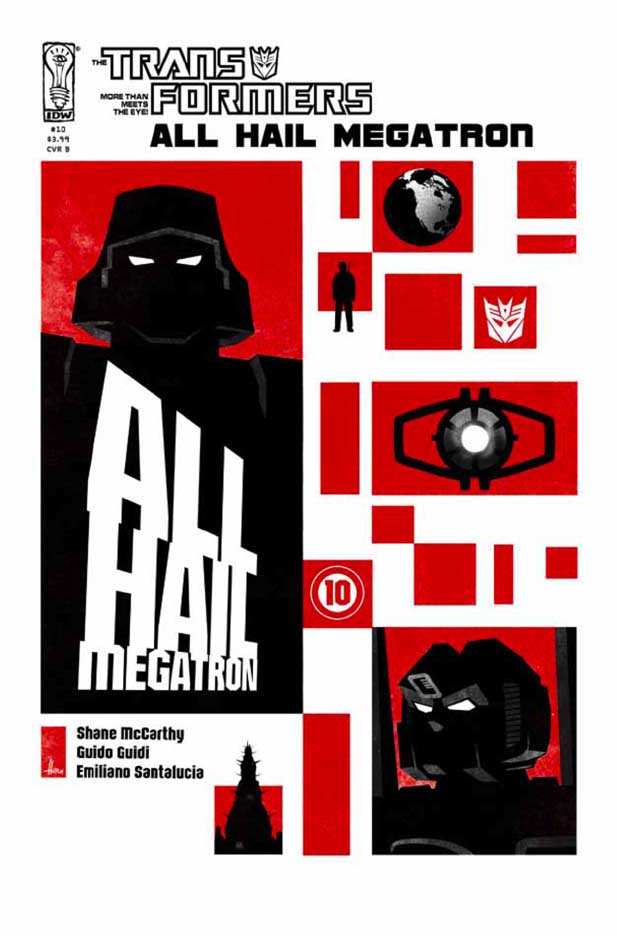What does the contrast of colors on the cover suggest about the tone or theme of the comic? The contrasting colors of red and black on the cover suggest a tone of tension and conflict. Red is often associated with power, danger, and intensity, indicative of an impending struggle or critical event, fitting with the Transformers' theme of intergalactic warfare. Black, on the other hand, denotes darkness, mystery, and sometimes evil, hinting at an antagonistic force, possibly Megatron's dominance or sinister plans. The bold proclamation, 'ALL HAIL MEGATRON,' reinforces the idea of a significant power shift or a pivotal conflict surrounding Megatron's influence in the narrative. 